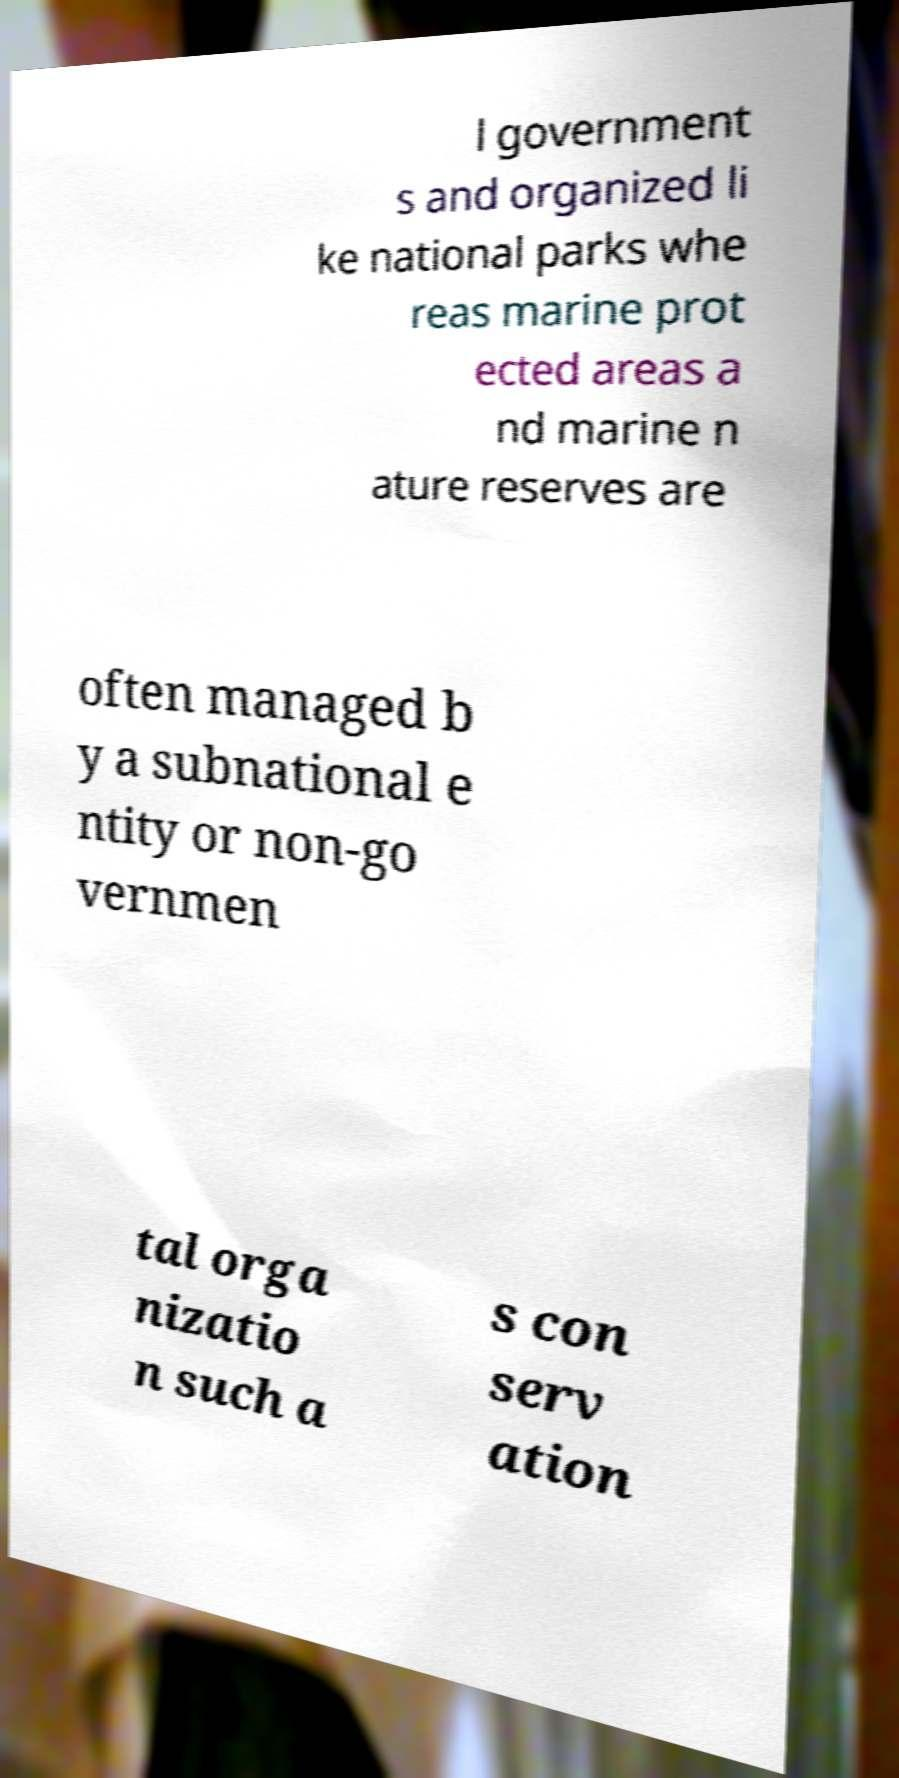Could you extract and type out the text from this image? l government s and organized li ke national parks whe reas marine prot ected areas a nd marine n ature reserves are often managed b y a subnational e ntity or non-go vernmen tal orga nizatio n such a s con serv ation 